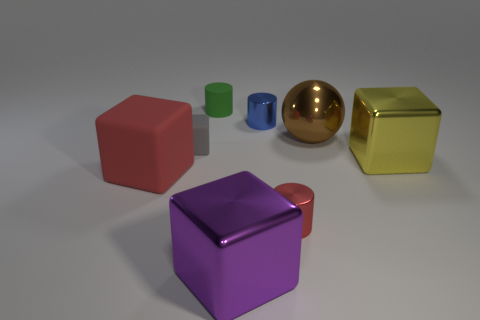Subtract 1 blocks. How many blocks are left? 3 Subtract all brown cylinders. Subtract all red spheres. How many cylinders are left? 3 Add 1 big things. How many objects exist? 9 Subtract all balls. How many objects are left? 7 Add 1 big blue balls. How many big blue balls exist? 1 Subtract 0 cyan balls. How many objects are left? 8 Subtract all tiny brown rubber balls. Subtract all blue metal cylinders. How many objects are left? 7 Add 5 tiny red metal cylinders. How many tiny red metal cylinders are left? 6 